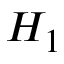<formula> <loc_0><loc_0><loc_500><loc_500>H _ { 1 }</formula> 